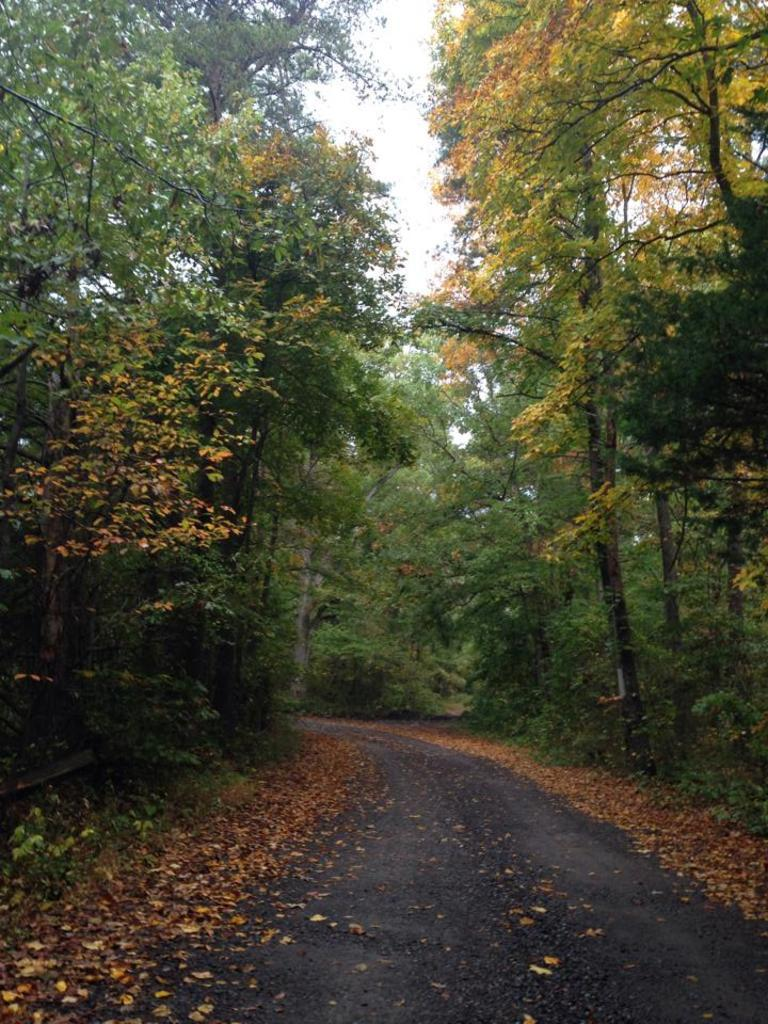What is located at the bottom of the image? There is a road at the bottom of the image. What type of vegetation can be seen on both sides of the image? There are trees on either side of the image. What is visible at the top of the image? The sky is visible at the top of the image. What type of cloth is hanging from the trees in the image? There is no cloth hanging from the trees in the image; only trees are present. What kind of relation does the robin have with the road in the image? There is no robin present in the image, so it cannot have any relation with the road. 